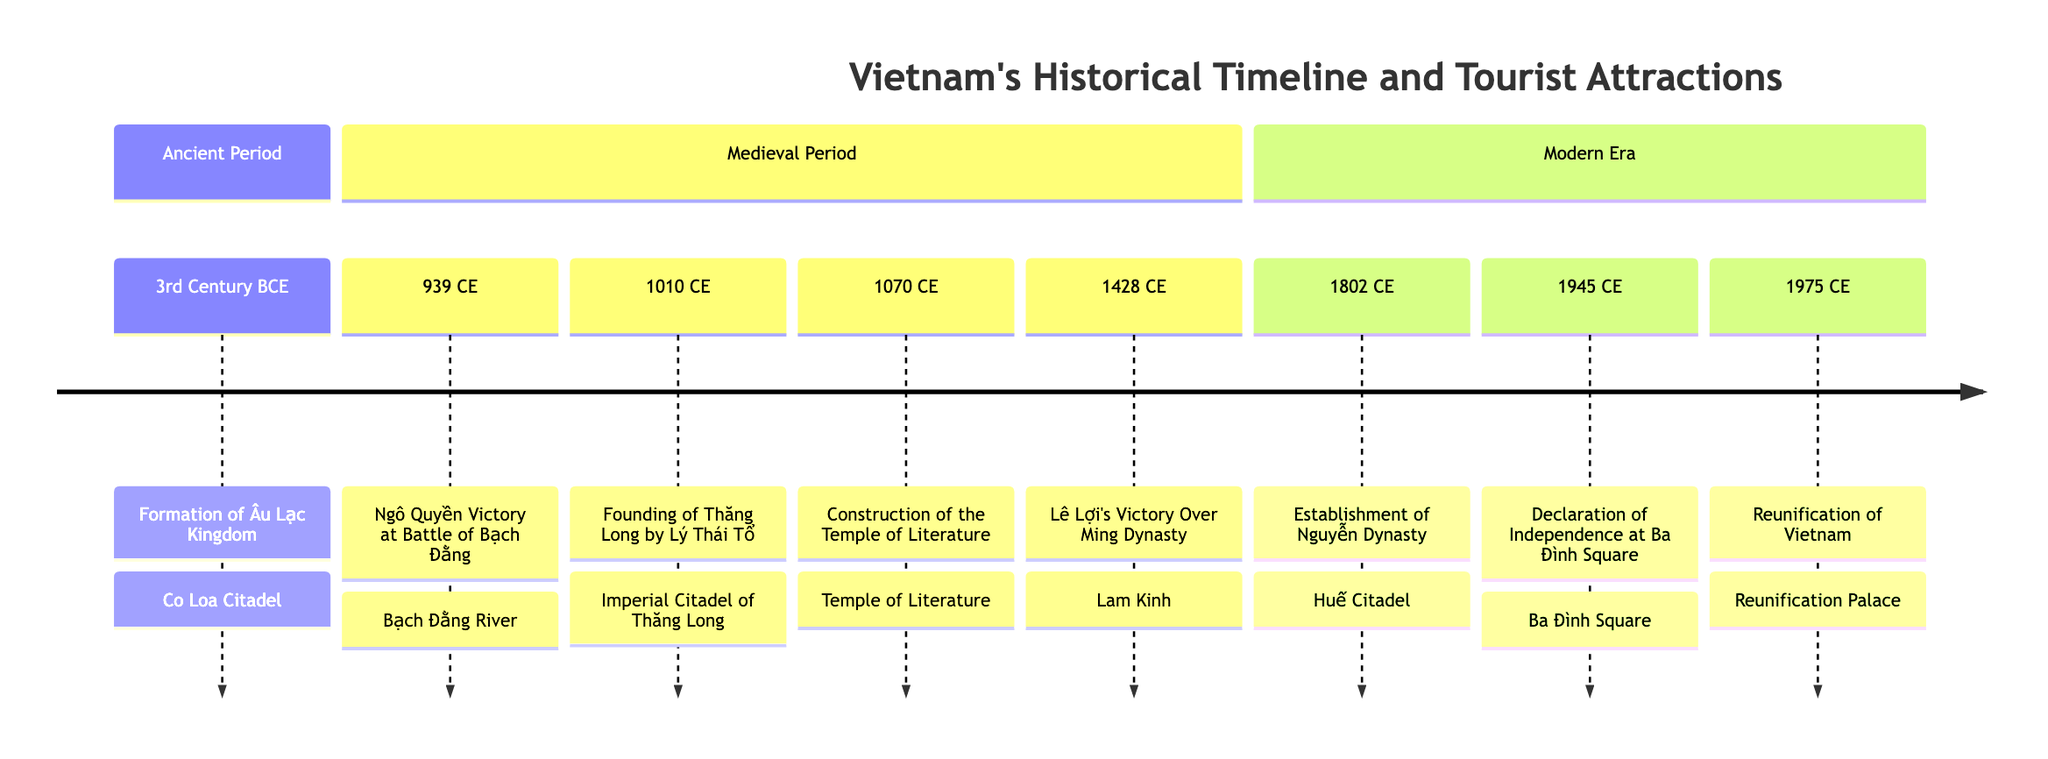What key event occurred in the 3rd Century BCE? The diagram shows that the formation of the Âu Lạc Kingdom took place in the 3rd Century BCE. Thus, this date corresponds to that specific event.
Answer: Formation of Âu Lạc Kingdom Which tourist attraction corresponds to Lý Thái Tổ's founding year? The diagram indicates that the founding of Thăng Long by Lý Thái Tổ occurred in 1010 CE, which directly links this event with the location of the Imperial Citadel of Thăng Long.
Answer: Imperial Citadel of Thăng Long How many key events are listed in the Medieval Period? The timeline details four predominant events occurring during the Medieval Period. By counting the events from 939 CE to 1428 CE, we find four significant historical milestones.
Answer: 4 What marks the end of the Modern Era in this timeline? The diagram specifies that the reunification of Vietnam in 1975 CE marks the conclusion of the Modern Era in this historical timeline, indicating a pivotal moment in Vietnam's history.
Answer: 1975 CE Which landmark is associated with the Declaration of Independence? According to the timeline, the Declaration of Independence at Ba Đình Square occurred in 1945 CE, thus connecting this significant historical event directly with Ba Đình Square.
Answer: Ba Đình Square What was the first key event listed in the timeline? The timeline displays the formation of the Âu Lạc Kingdom as the first event at the 3rd Century BCE mark, establishing it as the earliest recorded occurrence in this sequence.
Answer: Formation of Âu Lạc Kingdom What tourist attraction is linked to Lê Lợi's victory? The diagram indicates that Lê Lợi's Victory Over the Ming Dynasty in 1428 CE is associated with Lam Kinh, highlighting this landmark as a site of historical significance.
Answer: Lam Kinh How many sections are represented in the timeline? The timeline is divided into three distinct sections: Ancient Period, Medieval Period, and Modern Era. Counting these sections yields a total of three.
Answer: 3 